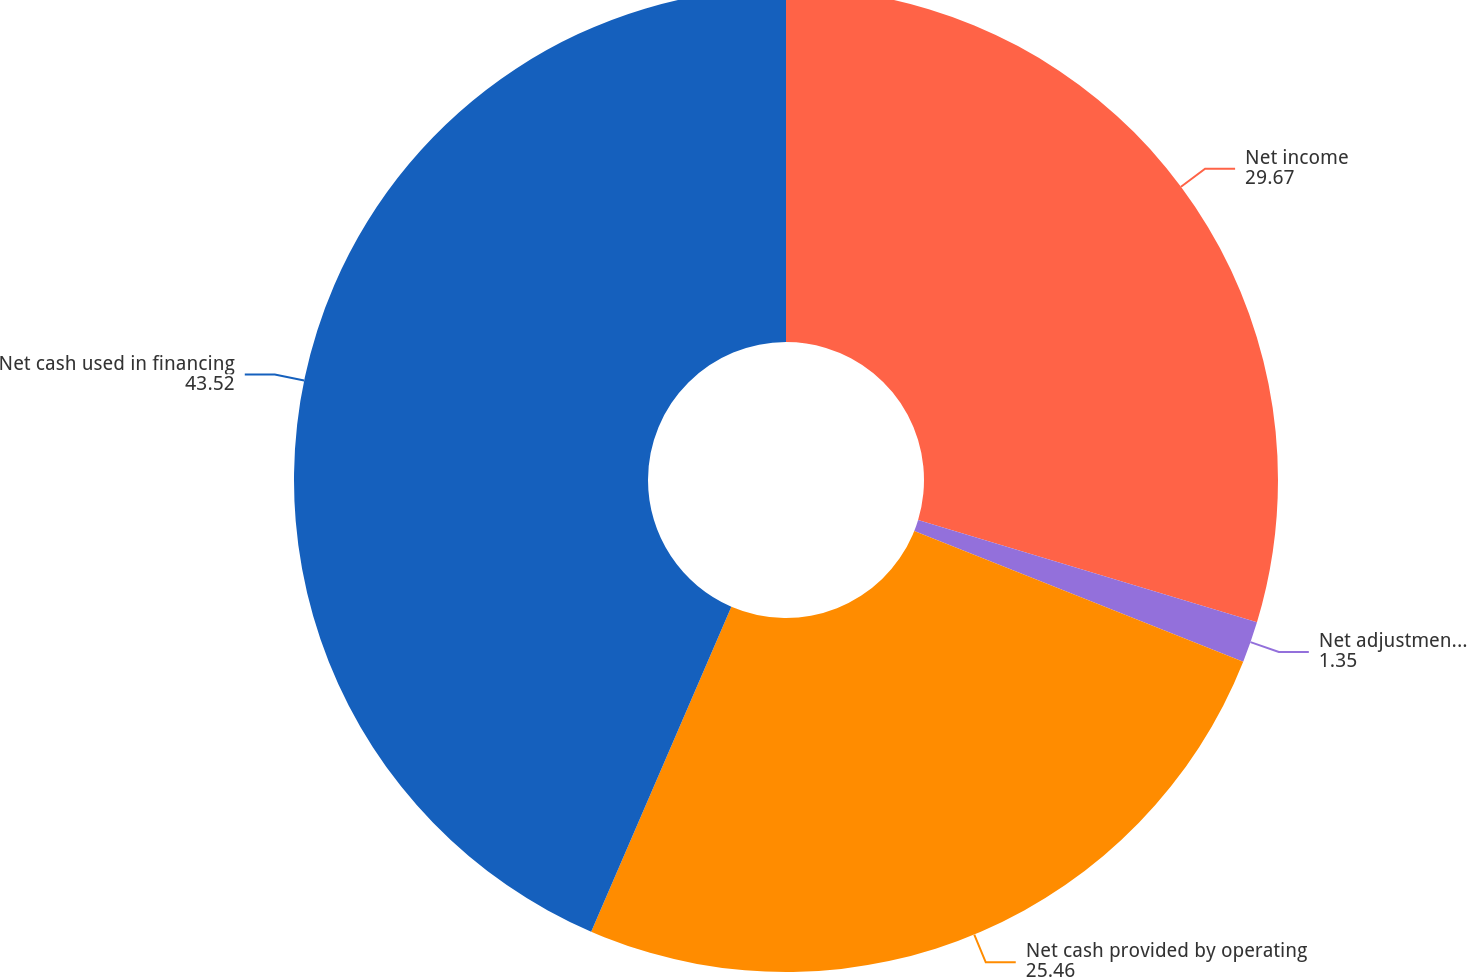Convert chart to OTSL. <chart><loc_0><loc_0><loc_500><loc_500><pie_chart><fcel>Net income<fcel>Net adjustments to reconcile<fcel>Net cash provided by operating<fcel>Net cash used in financing<nl><fcel>29.67%<fcel>1.35%<fcel>25.46%<fcel>43.52%<nl></chart> 